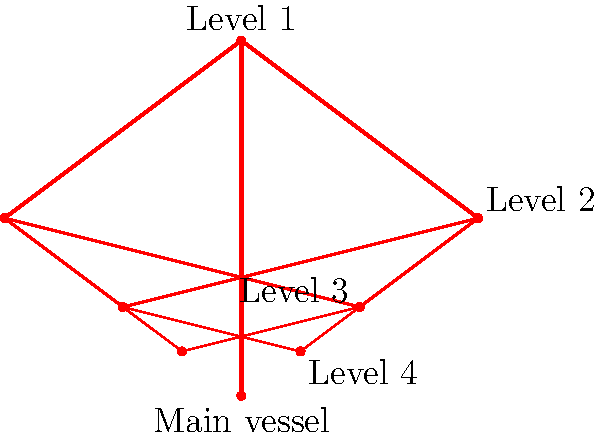In the context of blood vessel branching patterns, what topological property is exhibited by the circulatory system as illustrated in the diagram, and how does this relate to the efficiency of blood distribution in medical thriller scenarios involving vascular injuries? To answer this question, let's analyze the diagram step-by-step:

1. The diagram shows a hierarchical branching pattern of blood vessels, starting from a main vessel and splitting into smaller vessels at each level.

2. This branching pattern exhibits a topological property known as self-similarity or fractal-like structure. Each branch resembles a smaller version of the whole structure.

3. The self-similarity is evident in how:
   a) The main vessel splits into two branches at Level 1
   b) Each branch at Level 1 splits into two branches at Level 2
   c) This pattern continues down to Level 4

4. This fractal-like structure relates to the efficiency of blood distribution in several ways:
   a) It maximizes the surface area for nutrient and oxygen exchange
   b) It allows for even distribution of blood throughout the body
   c) It provides redundancy in blood flow, which is crucial in injury scenarios

5. In medical thriller scenarios involving vascular injuries:
   a) The redundancy in blood flow pathways allows for collateral circulation, potentially reducing the severity of ischemia in affected areas
   b) The hierarchical structure enables localized response to injuries, potentially limiting blood loss
   c) The fractal nature of the system makes it more resilient to damage, as the overall structure remains functional even if some branches are compromised

6. This topological property ensures that even in cases of vascular trauma, the circulatory system can often maintain some level of blood flow to vital organs, a critical factor in survival scenarios often depicted in medical thrillers.

Therefore, the topological property exhibited is self-similarity or fractal-like structure, which contributes significantly to the robustness and efficiency of the circulatory system, especially in trauma scenarios.
Answer: Self-similarity (fractal-like structure) 